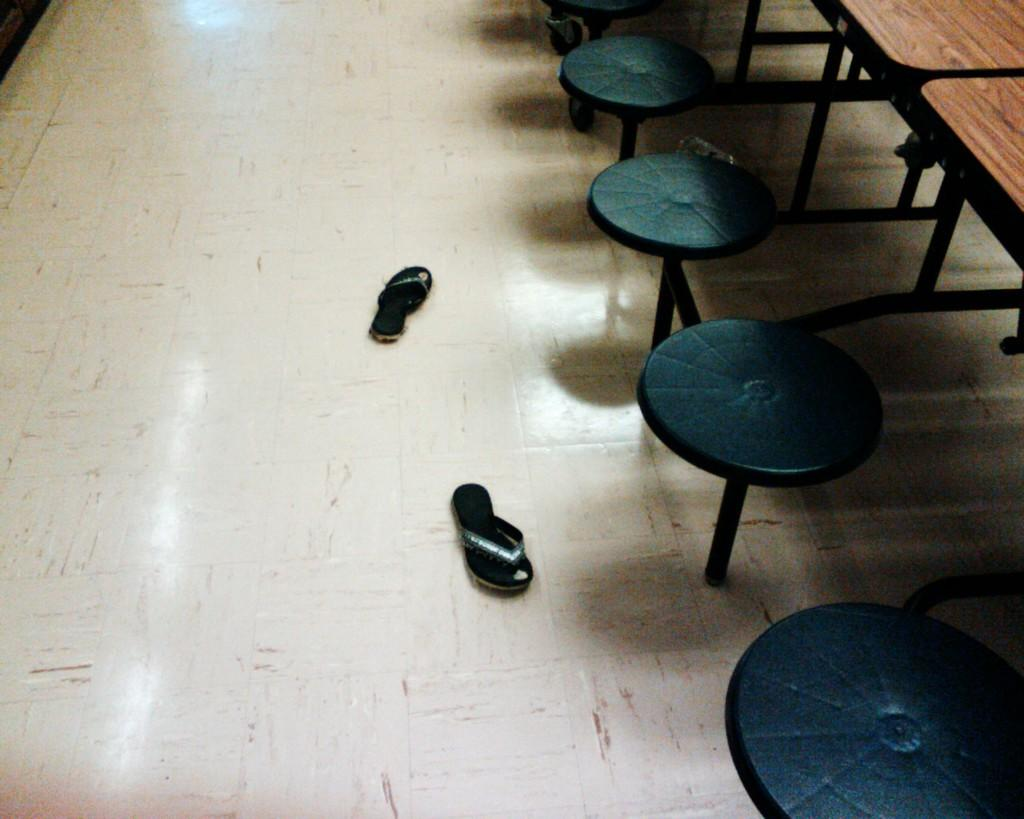What is placed on the floor in the image? There is a pair of footwear on the floor. What type of furniture is present in the image? There are stools and wooden tables in the image. How much money is on the table in the image? There is no mention of money in the image; it only features a pair of footwear, stools, and wooden tables. 